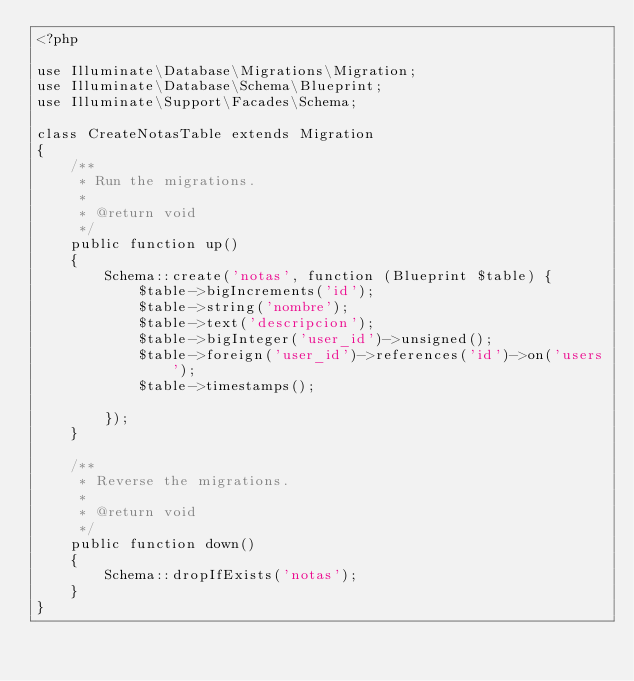Convert code to text. <code><loc_0><loc_0><loc_500><loc_500><_PHP_><?php

use Illuminate\Database\Migrations\Migration;
use Illuminate\Database\Schema\Blueprint;
use Illuminate\Support\Facades\Schema;

class CreateNotasTable extends Migration
{
    /**
     * Run the migrations.
     *
     * @return void
     */
    public function up()
    {
        Schema::create('notas', function (Blueprint $table) {
            $table->bigIncrements('id');
            $table->string('nombre');
            $table->text('descripcion');
            $table->bigInteger('user_id')->unsigned();
            $table->foreign('user_id')->references('id')->on('users');
            $table->timestamps();

        });
    }

    /**
     * Reverse the migrations.
     *
     * @return void
     */
    public function down()
    {
        Schema::dropIfExists('notas');
    }
}
</code> 